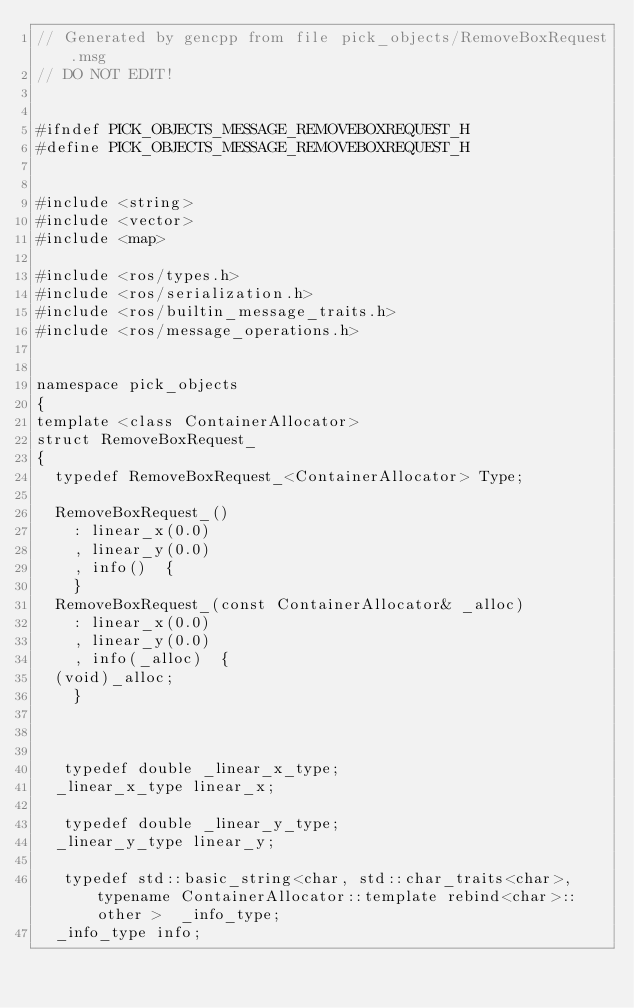Convert code to text. <code><loc_0><loc_0><loc_500><loc_500><_C_>// Generated by gencpp from file pick_objects/RemoveBoxRequest.msg
// DO NOT EDIT!


#ifndef PICK_OBJECTS_MESSAGE_REMOVEBOXREQUEST_H
#define PICK_OBJECTS_MESSAGE_REMOVEBOXREQUEST_H


#include <string>
#include <vector>
#include <map>

#include <ros/types.h>
#include <ros/serialization.h>
#include <ros/builtin_message_traits.h>
#include <ros/message_operations.h>


namespace pick_objects
{
template <class ContainerAllocator>
struct RemoveBoxRequest_
{
  typedef RemoveBoxRequest_<ContainerAllocator> Type;

  RemoveBoxRequest_()
    : linear_x(0.0)
    , linear_y(0.0)
    , info()  {
    }
  RemoveBoxRequest_(const ContainerAllocator& _alloc)
    : linear_x(0.0)
    , linear_y(0.0)
    , info(_alloc)  {
  (void)_alloc;
    }



   typedef double _linear_x_type;
  _linear_x_type linear_x;

   typedef double _linear_y_type;
  _linear_y_type linear_y;

   typedef std::basic_string<char, std::char_traits<char>, typename ContainerAllocator::template rebind<char>::other >  _info_type;
  _info_type info;




</code> 